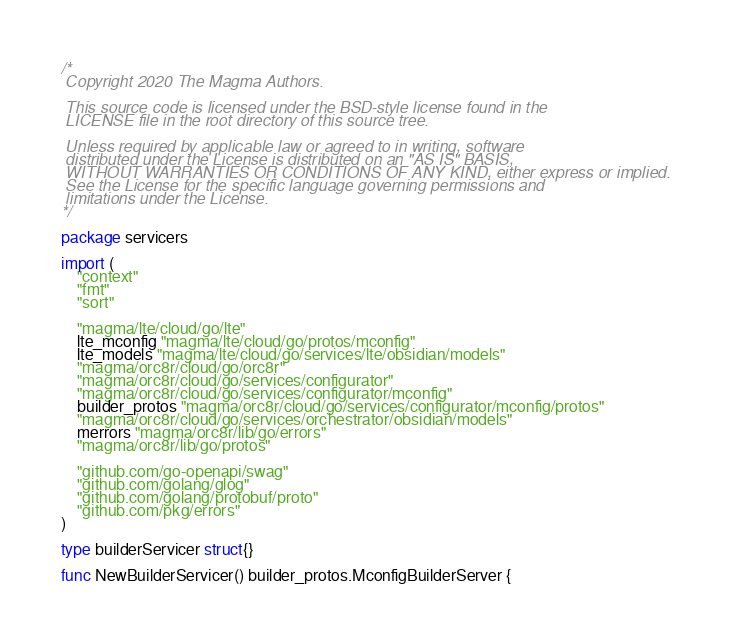<code> <loc_0><loc_0><loc_500><loc_500><_Go_>/*
 Copyright 2020 The Magma Authors.

 This source code is licensed under the BSD-style license found in the
 LICENSE file in the root directory of this source tree.

 Unless required by applicable law or agreed to in writing, software
 distributed under the License is distributed on an "AS IS" BASIS,
 WITHOUT WARRANTIES OR CONDITIONS OF ANY KIND, either express or implied.
 See the License for the specific language governing permissions and
 limitations under the License.
*/

package servicers

import (
	"context"
	"fmt"
	"sort"

	"magma/lte/cloud/go/lte"
	lte_mconfig "magma/lte/cloud/go/protos/mconfig"
	lte_models "magma/lte/cloud/go/services/lte/obsidian/models"
	"magma/orc8r/cloud/go/orc8r"
	"magma/orc8r/cloud/go/services/configurator"
	"magma/orc8r/cloud/go/services/configurator/mconfig"
	builder_protos "magma/orc8r/cloud/go/services/configurator/mconfig/protos"
	"magma/orc8r/cloud/go/services/orchestrator/obsidian/models"
	merrors "magma/orc8r/lib/go/errors"
	"magma/orc8r/lib/go/protos"

	"github.com/go-openapi/swag"
	"github.com/golang/glog"
	"github.com/golang/protobuf/proto"
	"github.com/pkg/errors"
)

type builderServicer struct{}

func NewBuilderServicer() builder_protos.MconfigBuilderServer {</code> 